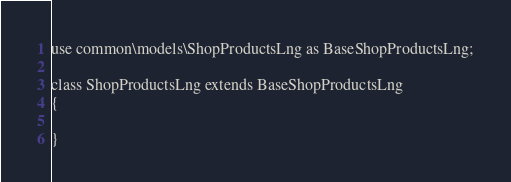Convert code to text. <code><loc_0><loc_0><loc_500><loc_500><_PHP_>
use common\models\ShopProductsLng as BaseShopProductsLng;

class ShopProductsLng extends BaseShopProductsLng
{

}</code> 